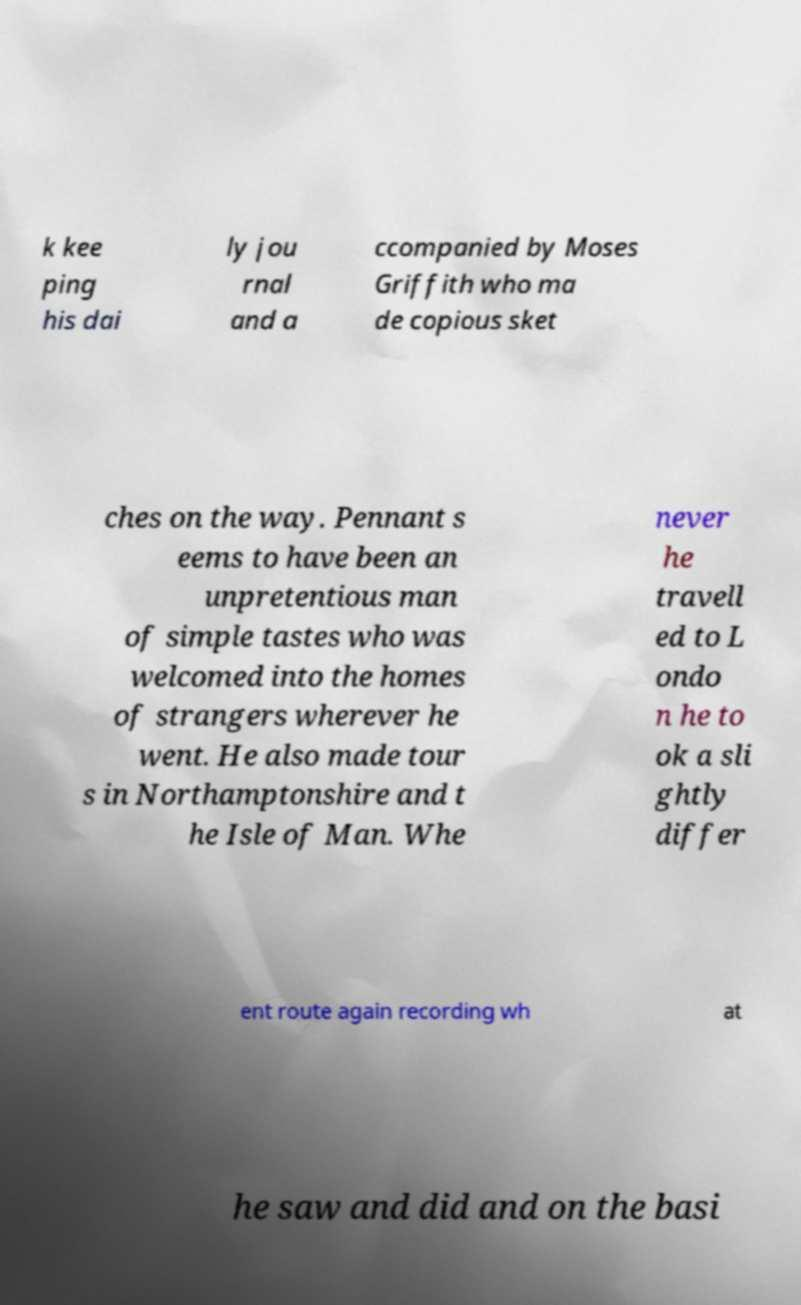Please read and relay the text visible in this image. What does it say? k kee ping his dai ly jou rnal and a ccompanied by Moses Griffith who ma de copious sket ches on the way. Pennant s eems to have been an unpretentious man of simple tastes who was welcomed into the homes of strangers wherever he went. He also made tour s in Northamptonshire and t he Isle of Man. Whe never he travell ed to L ondo n he to ok a sli ghtly differ ent route again recording wh at he saw and did and on the basi 